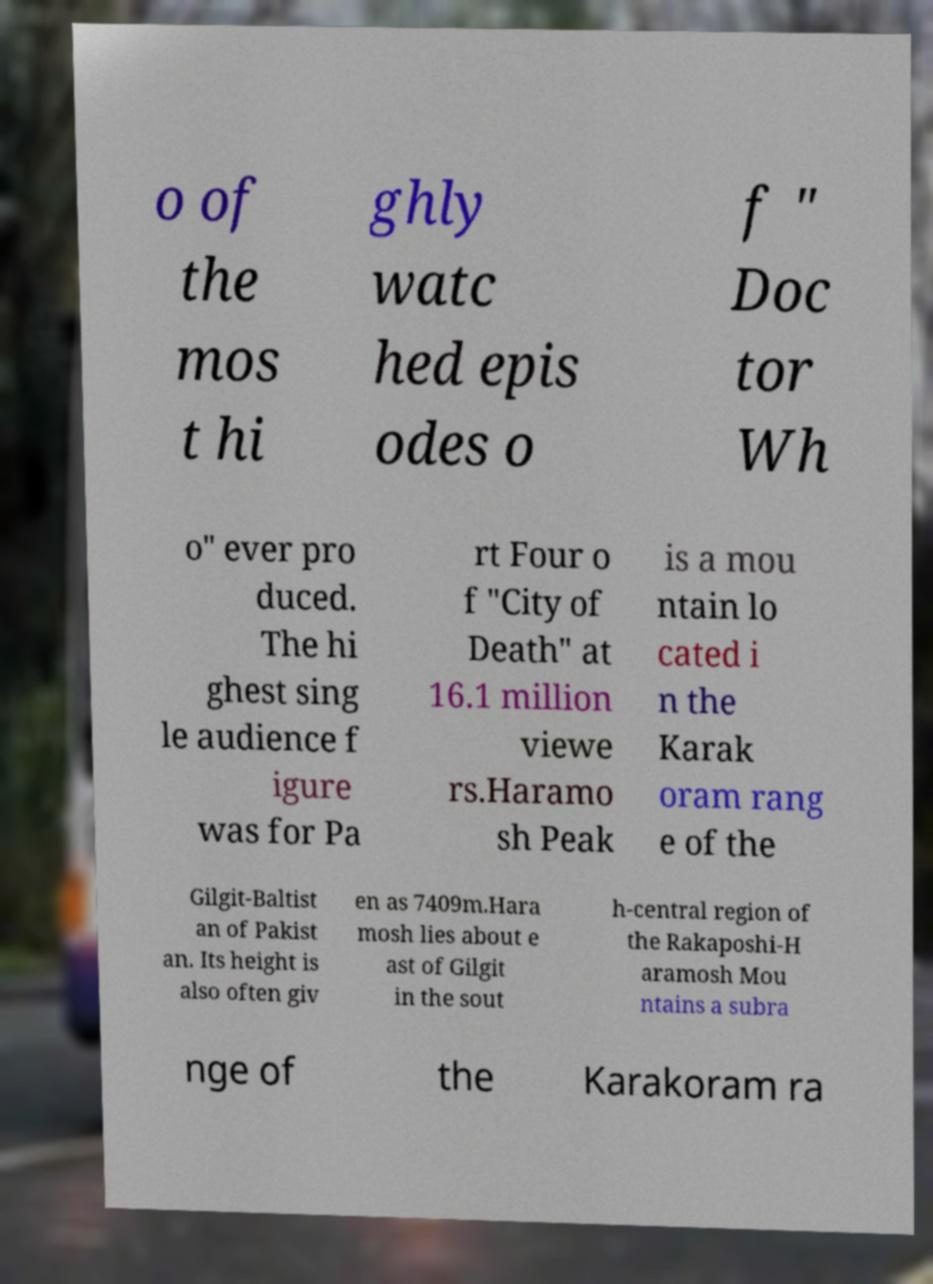What messages or text are displayed in this image? I need them in a readable, typed format. o of the mos t hi ghly watc hed epis odes o f " Doc tor Wh o" ever pro duced. The hi ghest sing le audience f igure was for Pa rt Four o f "City of Death" at 16.1 million viewe rs.Haramo sh Peak is a mou ntain lo cated i n the Karak oram rang e of the Gilgit-Baltist an of Pakist an. Its height is also often giv en as 7409m.Hara mosh lies about e ast of Gilgit in the sout h-central region of the Rakaposhi-H aramosh Mou ntains a subra nge of the Karakoram ra 